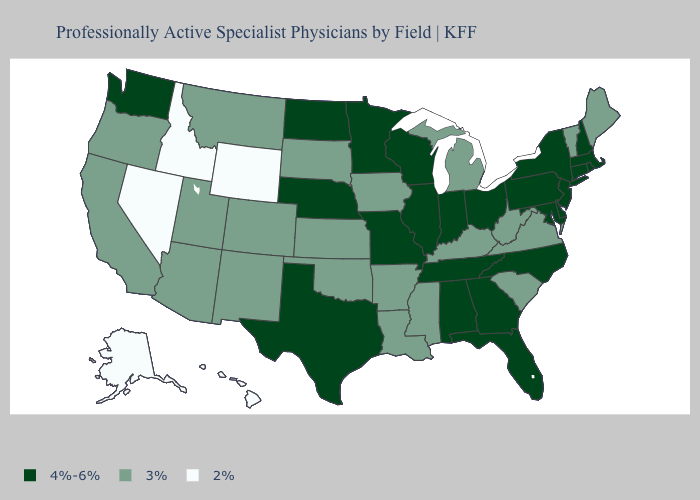How many symbols are there in the legend?
Concise answer only. 3. Does Iowa have the highest value in the USA?
Answer briefly. No. Does the map have missing data?
Short answer required. No. What is the value of Colorado?
Write a very short answer. 3%. What is the value of Rhode Island?
Quick response, please. 4%-6%. Does the first symbol in the legend represent the smallest category?
Be succinct. No. Does Connecticut have the highest value in the USA?
Give a very brief answer. Yes. Which states have the highest value in the USA?
Short answer required. Alabama, Connecticut, Delaware, Florida, Georgia, Illinois, Indiana, Maryland, Massachusetts, Minnesota, Missouri, Nebraska, New Hampshire, New Jersey, New York, North Carolina, North Dakota, Ohio, Pennsylvania, Rhode Island, Tennessee, Texas, Washington, Wisconsin. Does the map have missing data?
Keep it brief. No. Among the states that border North Dakota , which have the lowest value?
Answer briefly. Montana, South Dakota. What is the lowest value in states that border New Mexico?
Keep it brief. 3%. What is the value of Montana?
Write a very short answer. 3%. Among the states that border Oklahoma , which have the lowest value?
Keep it brief. Arkansas, Colorado, Kansas, New Mexico. Which states have the lowest value in the USA?
Give a very brief answer. Alaska, Hawaii, Idaho, Nevada, Wyoming. Which states have the highest value in the USA?
Give a very brief answer. Alabama, Connecticut, Delaware, Florida, Georgia, Illinois, Indiana, Maryland, Massachusetts, Minnesota, Missouri, Nebraska, New Hampshire, New Jersey, New York, North Carolina, North Dakota, Ohio, Pennsylvania, Rhode Island, Tennessee, Texas, Washington, Wisconsin. 